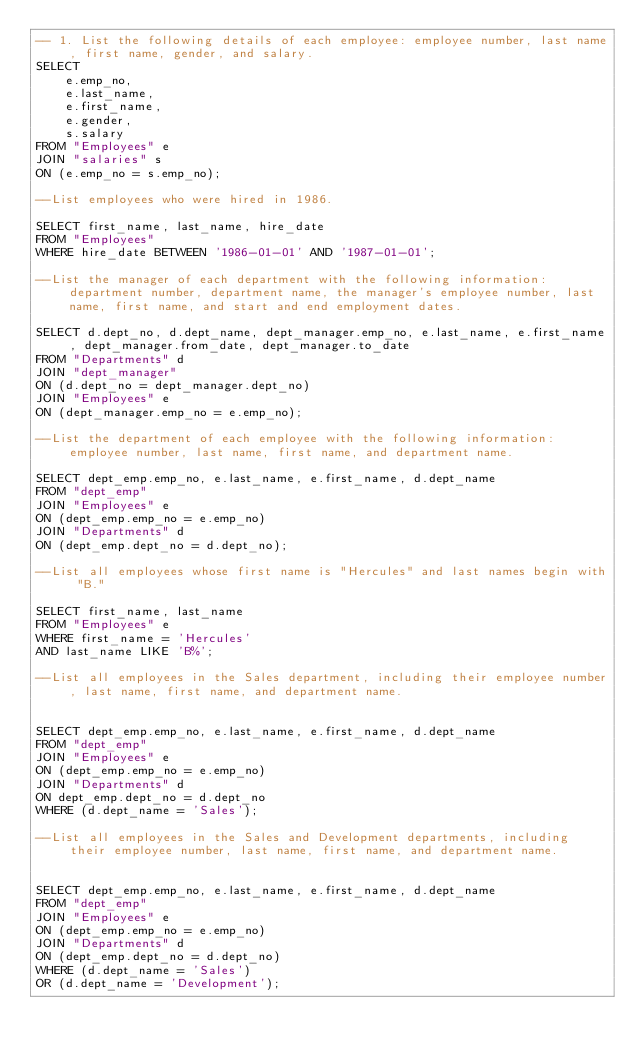Convert code to text. <code><loc_0><loc_0><loc_500><loc_500><_SQL_>-- 1. List the following details of each employee: employee number, last name, first name, gender, and salary.
SELECT 
    e.emp_no, 
    e.last_name, 
    e.first_name, 
    e.gender,
    s.salary
FROM "Employees" e
JOIN "salaries" s 
ON (e.emp_no = s.emp_no);

--List employees who were hired in 1986.

SELECT first_name, last_name, hire_date 
FROM "Employees" 
WHERE hire_date BETWEEN '1986-01-01' AND '1987-01-01';

--List the manager of each department with the following information: department number, department name, the manager's employee number, last name, first name, and start and end employment dates.

SELECT d.dept_no, d.dept_name, dept_manager.emp_no, e.last_name, e.first_name, dept_manager.from_date, dept_manager.to_date
FROM "Departments" d
JOIN "dept_manager"  
ON (d.dept_no = dept_manager.dept_no)
JOIN "Employees" e
ON (dept_manager.emp_no = e.emp_no);

--List the department of each employee with the following information: employee number, last name, first name, and department name.

SELECT dept_emp.emp_no, e.last_name, e.first_name, d.dept_name
FROM "dept_emp"
JOIN "Employees" e
ON (dept_emp.emp_no = e.emp_no)
JOIN "Departments" d
ON (dept_emp.dept_no = d.dept_no);

--List all employees whose first name is "Hercules" and last names begin with "B."

SELECT first_name, last_name
FROM "Employees" e
WHERE first_name = 'Hercules'
AND last_name LIKE 'B%';

--List all employees in the Sales department, including their employee number, last name, first name, and department name.


SELECT dept_emp.emp_no, e.last_name, e.first_name, d.dept_name
FROM "dept_emp"
JOIN "Employees" e
ON (dept_emp.emp_no = e.emp_no)
JOIN "Departments" d
ON dept_emp.dept_no = d.dept_no
WHERE (d.dept_name = 'Sales');

--List all employees in the Sales and Development departments, including their employee number, last name, first name, and department name.


SELECT dept_emp.emp_no, e.last_name, e.first_name, d.dept_name
FROM "dept_emp"
JOIN "Employees" e
ON (dept_emp.emp_no = e.emp_no)
JOIN "Departments" d
ON (dept_emp.dept_no = d.dept_no)
WHERE (d.dept_name = 'Sales') 
OR (d.dept_name = 'Development');
</code> 